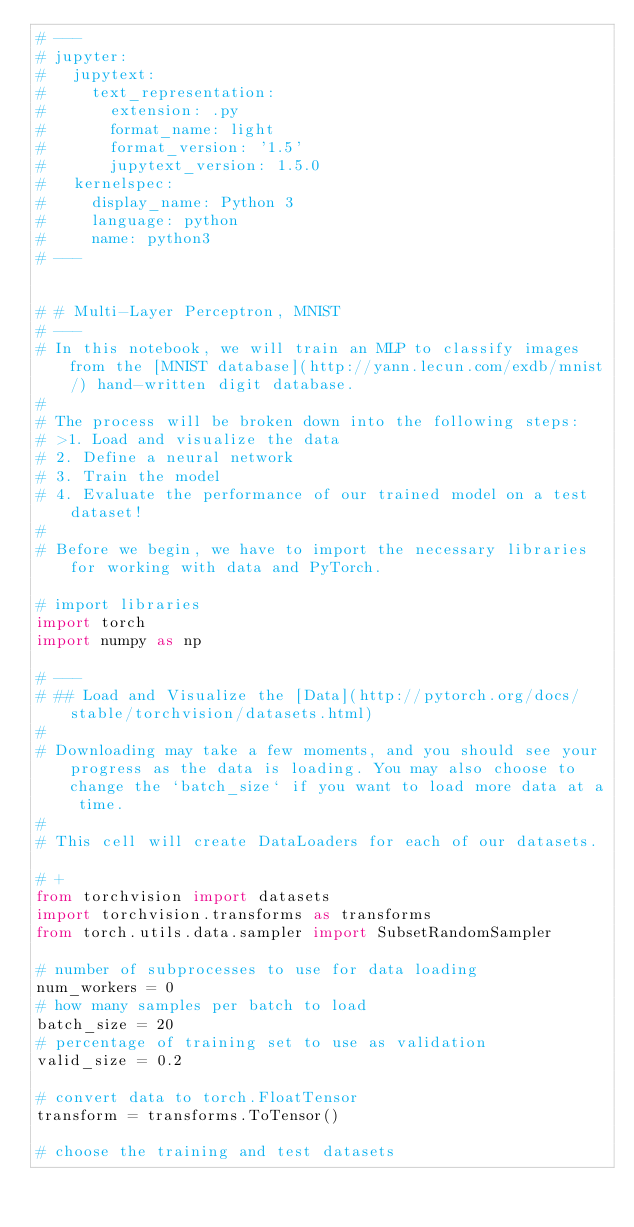Convert code to text. <code><loc_0><loc_0><loc_500><loc_500><_Python_># ---
# jupyter:
#   jupytext:
#     text_representation:
#       extension: .py
#       format_name: light
#       format_version: '1.5'
#       jupytext_version: 1.5.0
#   kernelspec:
#     display_name: Python 3
#     language: python
#     name: python3
# ---


# # Multi-Layer Perceptron, MNIST
# ---
# In this notebook, we will train an MLP to classify images from the [MNIST database](http://yann.lecun.com/exdb/mnist/) hand-written digit database.
#
# The process will be broken down into the following steps:
# >1. Load and visualize the data
# 2. Define a neural network
# 3. Train the model
# 4. Evaluate the performance of our trained model on a test dataset!
#
# Before we begin, we have to import the necessary libraries for working with data and PyTorch.

# import libraries
import torch
import numpy as np

# ---
# ## Load and Visualize the [Data](http://pytorch.org/docs/stable/torchvision/datasets.html)
#
# Downloading may take a few moments, and you should see your progress as the data is loading. You may also choose to change the `batch_size` if you want to load more data at a time.
#
# This cell will create DataLoaders for each of our datasets.

# +
from torchvision import datasets
import torchvision.transforms as transforms
from torch.utils.data.sampler import SubsetRandomSampler

# number of subprocesses to use for data loading
num_workers = 0
# how many samples per batch to load
batch_size = 20
# percentage of training set to use as validation
valid_size = 0.2

# convert data to torch.FloatTensor
transform = transforms.ToTensor()

# choose the training and test datasets</code> 